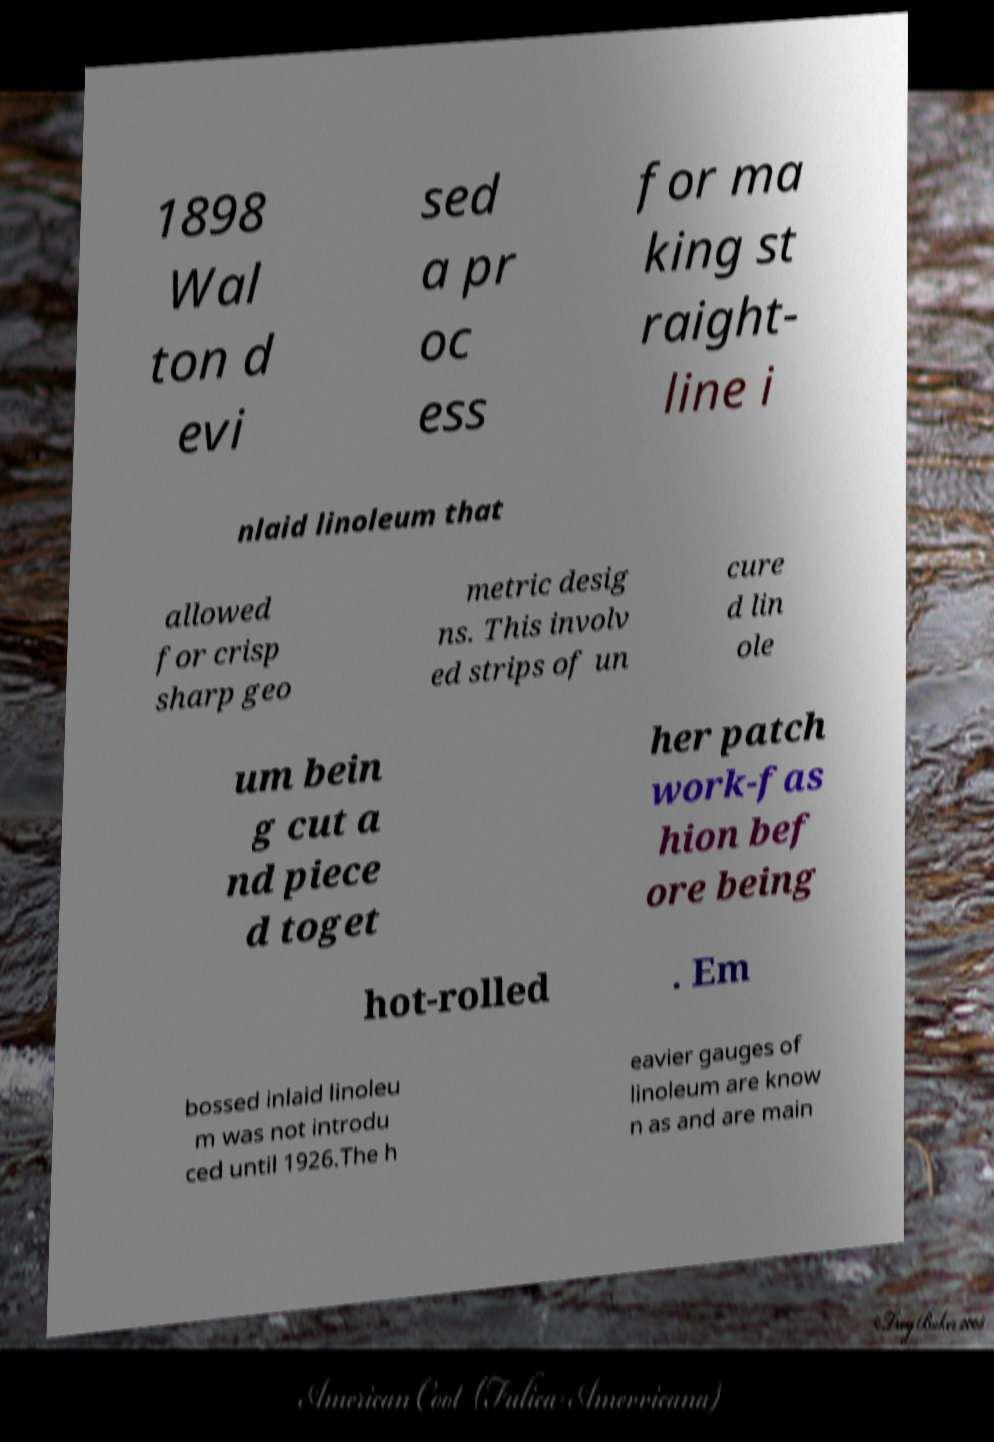For documentation purposes, I need the text within this image transcribed. Could you provide that? 1898 Wal ton d evi sed a pr oc ess for ma king st raight- line i nlaid linoleum that allowed for crisp sharp geo metric desig ns. This involv ed strips of un cure d lin ole um bein g cut a nd piece d toget her patch work-fas hion bef ore being hot-rolled . Em bossed inlaid linoleu m was not introdu ced until 1926.The h eavier gauges of linoleum are know n as and are main 